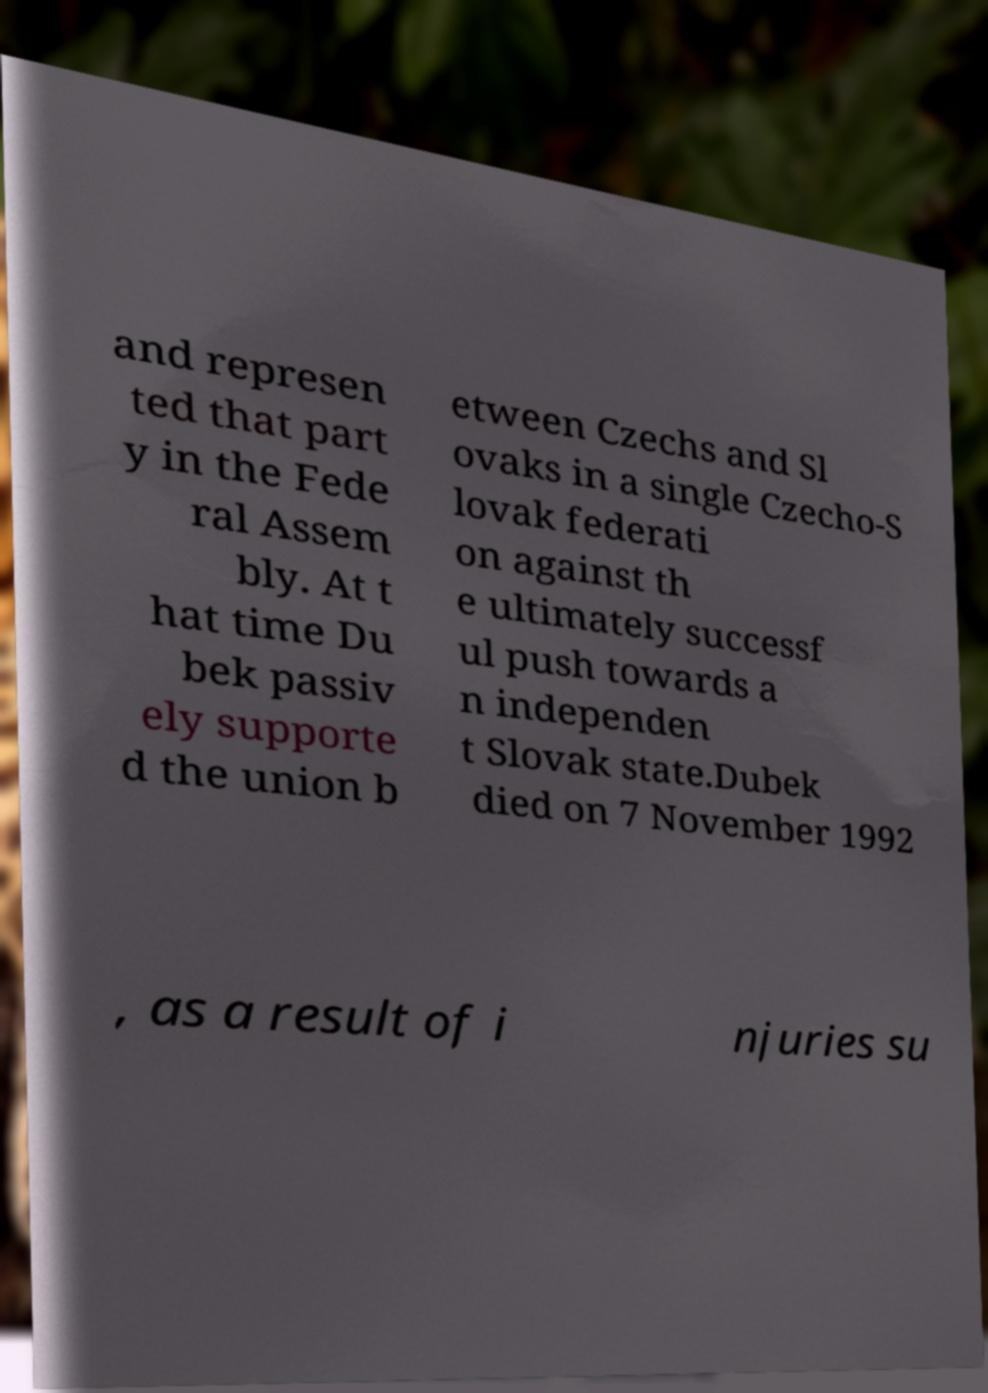I need the written content from this picture converted into text. Can you do that? and represen ted that part y in the Fede ral Assem bly. At t hat time Du bek passiv ely supporte d the union b etween Czechs and Sl ovaks in a single Czecho-S lovak federati on against th e ultimately successf ul push towards a n independen t Slovak state.Dubek died on 7 November 1992 , as a result of i njuries su 